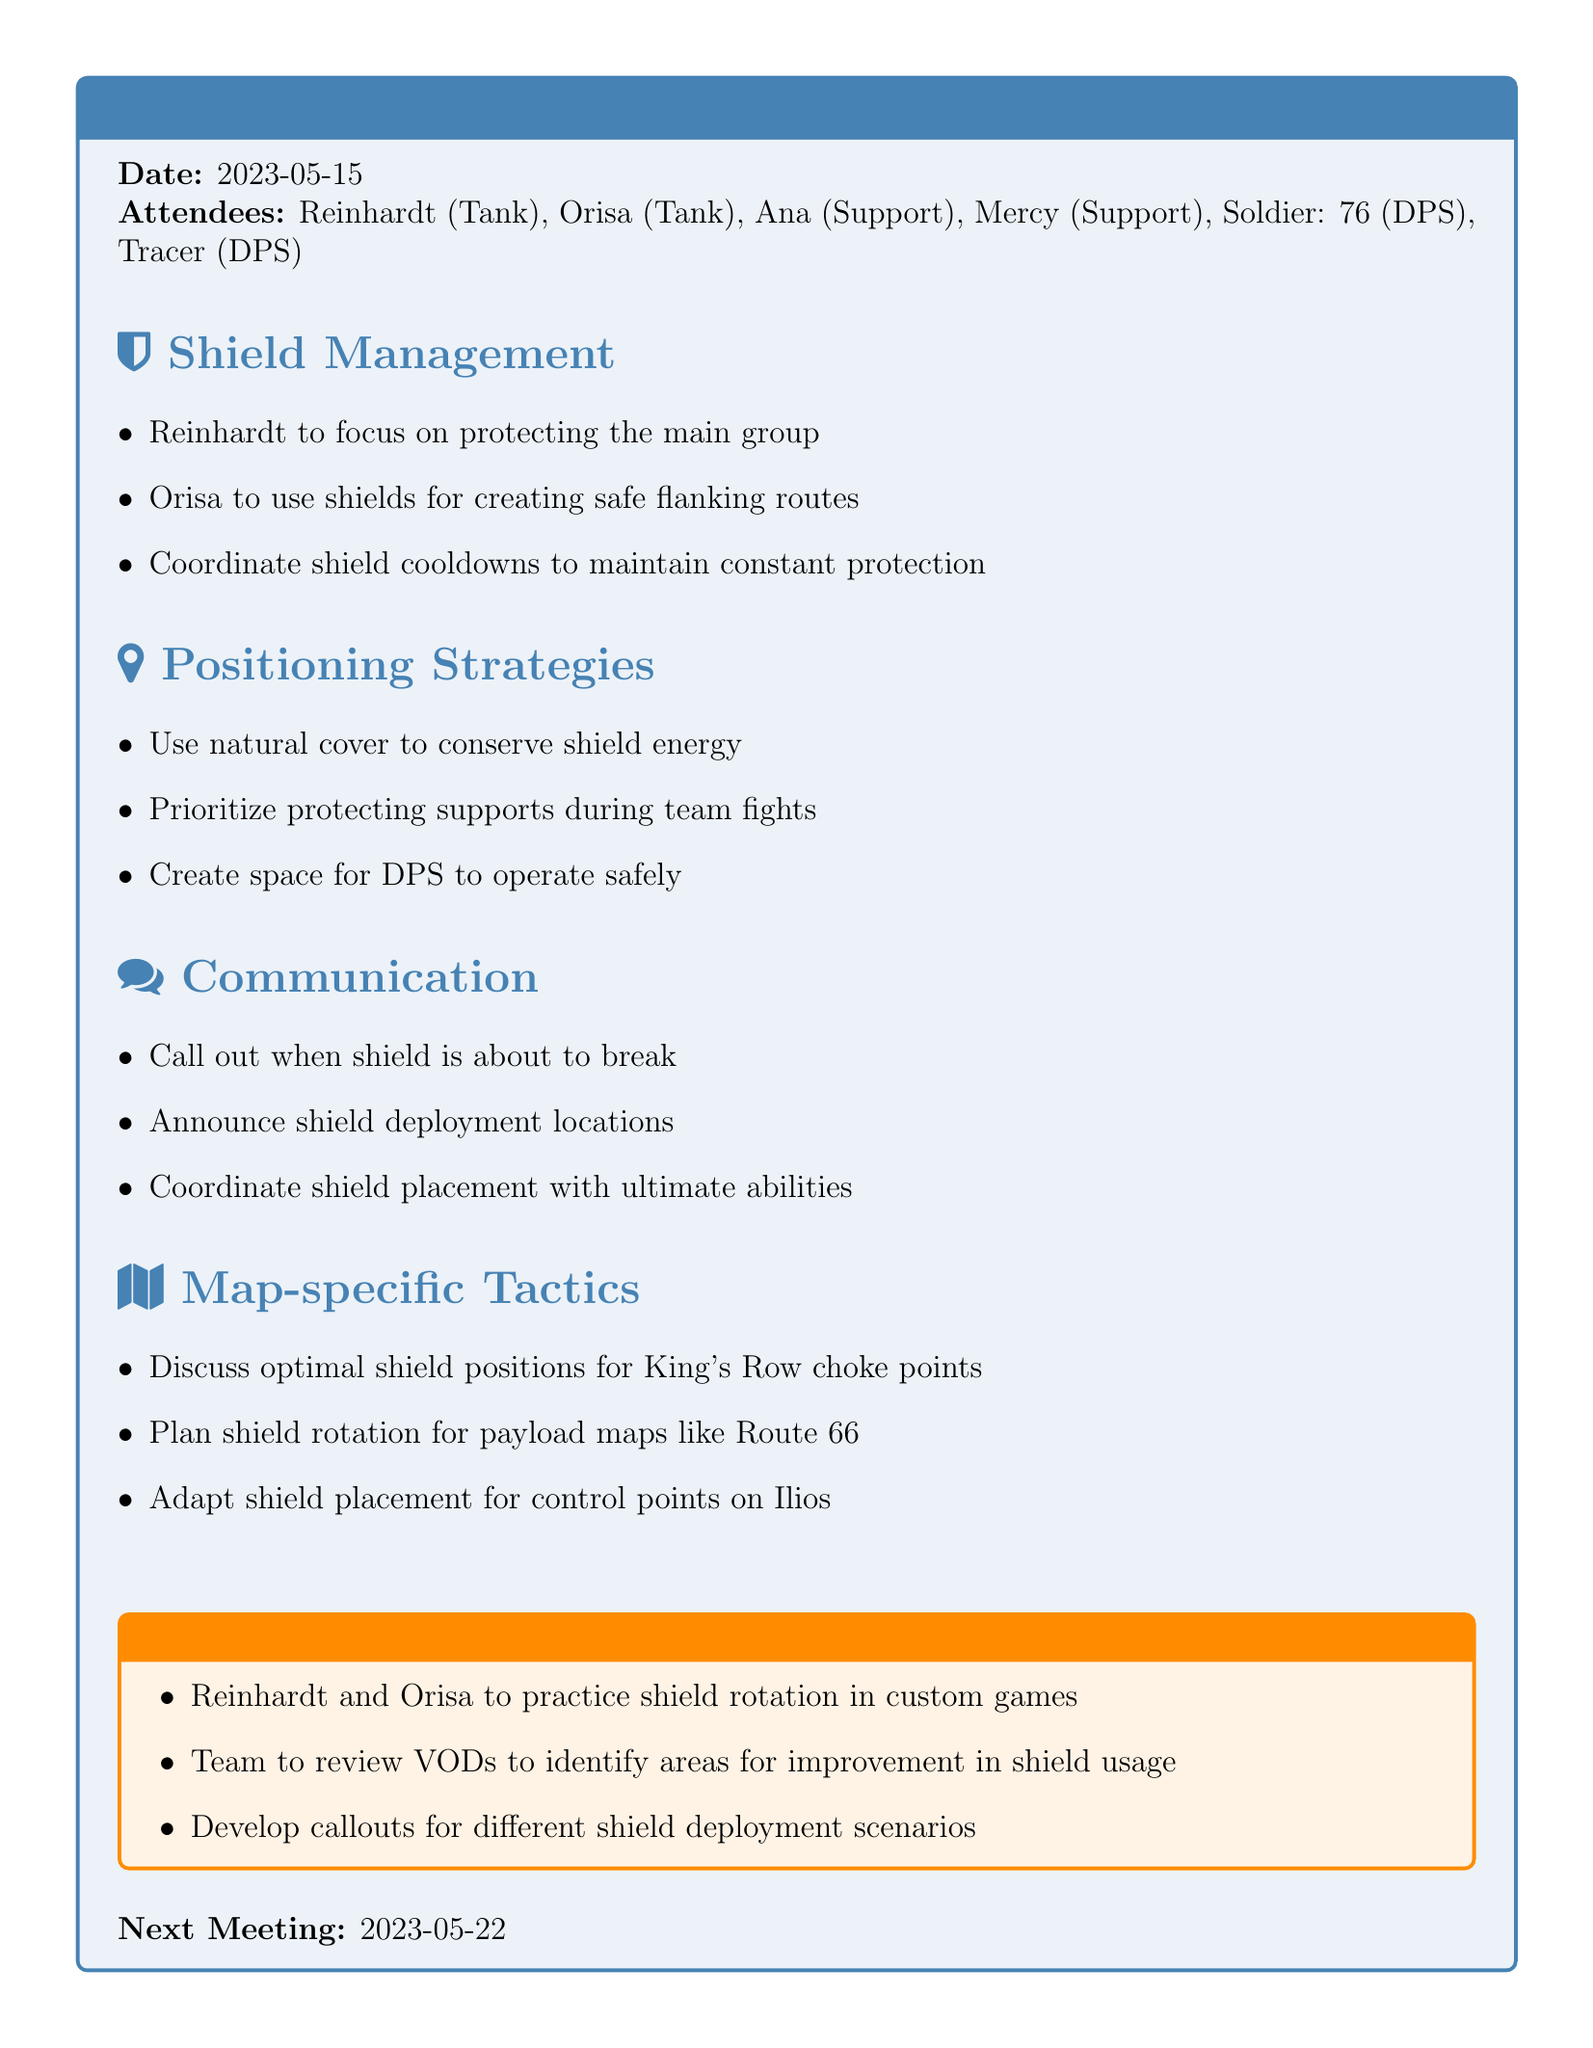What is the title of the meeting? The title is stated explicitly at the beginning of the document.
Answer: Team Strategy: Optimizing Shield Placement and Timing What date was the meeting held? The date is mentioned under the title section of the document.
Answer: 2023-05-15 Who are the attendees of the meeting? A list of attendees is provided, showing all members present for the meeting.
Answer: Reinhardt, Orisa, Ana, Mercy, Soldier: 76, Tracer What is one key point from the shield management section? The key points listed provide insight into the strategies discussed during the meeting.
Answer: Reinhardt to focus on protecting the main group What are the action items for the team? The document outlines specific tasks assigned to the team members as a result of the meeting.
Answer: Reinhardt and Orisa to practice shield rotation in custom games How often should shields be coordinated according to the discussion? The importance of maintaining constant protection indicates a frequency in shield coordination.
Answer: Constantly What is the next meeting date? The next meeting is specified at the end of the document for future reference.
Answer: 2023-05-22 What specific tactic was discussed for King's Row? The map-specific tactics section addresses optimal shield positions for specific locations.
Answer: Optimal shield positions for King's Row choke points Which two tanks are responsible for practicing shield rotation? Specific action items point out responsible individuals for training sessions.
Answer: Reinhardt and Orisa What is emphasized as a priority during team fights? The positioning strategies section highlights the need to prioritize certain roles during engagements.
Answer: Protecting supports 